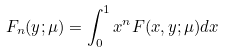<formula> <loc_0><loc_0><loc_500><loc_500>F _ { n } ( y ; \mu ) = \int _ { 0 } ^ { 1 } x ^ { n } F ( x , y ; \mu ) d x</formula> 